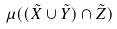<formula> <loc_0><loc_0><loc_500><loc_500>\mu ( ( \tilde { X } \cup \tilde { Y } ) \cap \tilde { Z } )</formula> 